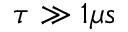<formula> <loc_0><loc_0><loc_500><loc_500>\tau \gg 1 \mu s</formula> 